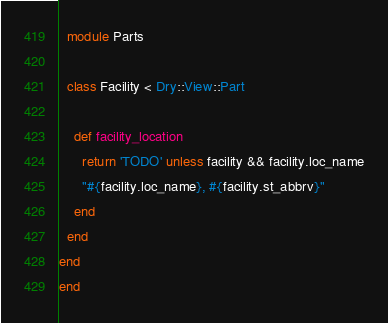<code> <loc_0><loc_0><loc_500><loc_500><_Ruby_>  module Parts

  class Facility < Dry::View::Part

    def facility_location
      return 'TODO' unless facility && facility.loc_name
      "#{facility.loc_name}, #{facility.st_abbrv}"
    end
  end
end
end 
</code> 